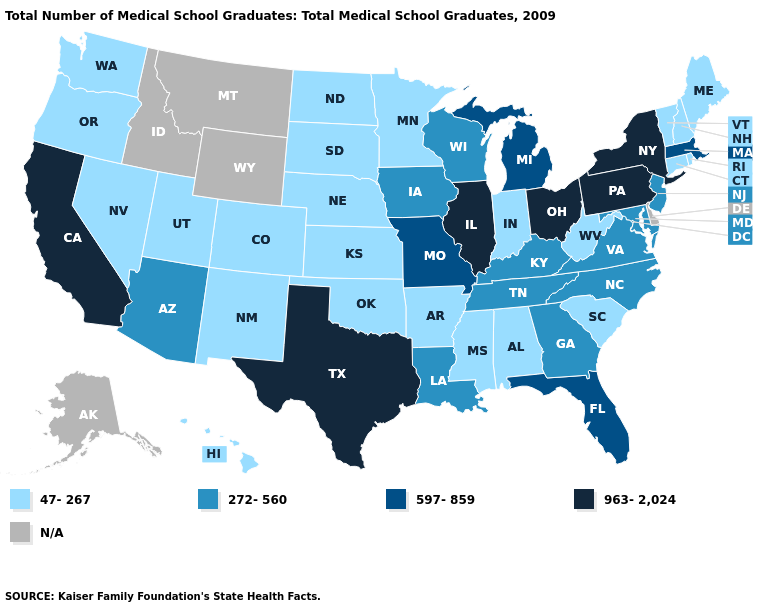Name the states that have a value in the range 272-560?
Concise answer only. Arizona, Georgia, Iowa, Kentucky, Louisiana, Maryland, New Jersey, North Carolina, Tennessee, Virginia, Wisconsin. What is the value of Connecticut?
Short answer required. 47-267. Name the states that have a value in the range 47-267?
Short answer required. Alabama, Arkansas, Colorado, Connecticut, Hawaii, Indiana, Kansas, Maine, Minnesota, Mississippi, Nebraska, Nevada, New Hampshire, New Mexico, North Dakota, Oklahoma, Oregon, Rhode Island, South Carolina, South Dakota, Utah, Vermont, Washington, West Virginia. Name the states that have a value in the range 272-560?
Keep it brief. Arizona, Georgia, Iowa, Kentucky, Louisiana, Maryland, New Jersey, North Carolina, Tennessee, Virginia, Wisconsin. Which states hav the highest value in the MidWest?
Concise answer only. Illinois, Ohio. Name the states that have a value in the range 597-859?
Be succinct. Florida, Massachusetts, Michigan, Missouri. What is the value of New Hampshire?
Answer briefly. 47-267. Does Illinois have the highest value in the USA?
Short answer required. Yes. Among the states that border New Jersey , which have the highest value?
Concise answer only. New York, Pennsylvania. What is the value of Illinois?
Be succinct. 963-2,024. How many symbols are there in the legend?
Short answer required. 5. What is the highest value in the USA?
Keep it brief. 963-2,024. Does Virginia have the highest value in the USA?
Give a very brief answer. No. What is the value of Maryland?
Answer briefly. 272-560. 